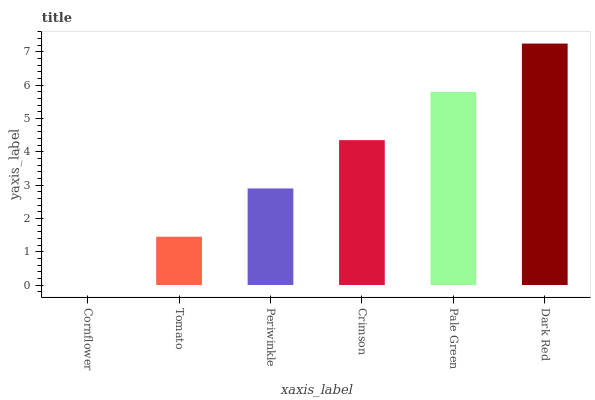Is Cornflower the minimum?
Answer yes or no. Yes. Is Dark Red the maximum?
Answer yes or no. Yes. Is Tomato the minimum?
Answer yes or no. No. Is Tomato the maximum?
Answer yes or no. No. Is Tomato greater than Cornflower?
Answer yes or no. Yes. Is Cornflower less than Tomato?
Answer yes or no. Yes. Is Cornflower greater than Tomato?
Answer yes or no. No. Is Tomato less than Cornflower?
Answer yes or no. No. Is Crimson the high median?
Answer yes or no. Yes. Is Periwinkle the low median?
Answer yes or no. Yes. Is Pale Green the high median?
Answer yes or no. No. Is Pale Green the low median?
Answer yes or no. No. 